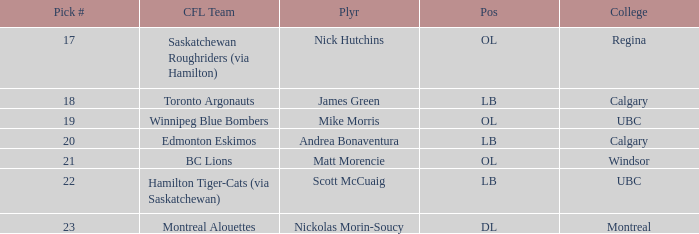Would you mind parsing the complete table? {'header': ['Pick #', 'CFL Team', 'Plyr', 'Pos', 'College'], 'rows': [['17', 'Saskatchewan Roughriders (via Hamilton)', 'Nick Hutchins', 'OL', 'Regina'], ['18', 'Toronto Argonauts', 'James Green', 'LB', 'Calgary'], ['19', 'Winnipeg Blue Bombers', 'Mike Morris', 'OL', 'UBC'], ['20', 'Edmonton Eskimos', 'Andrea Bonaventura', 'LB', 'Calgary'], ['21', 'BC Lions', 'Matt Morencie', 'OL', 'Windsor'], ['22', 'Hamilton Tiger-Cats (via Saskatchewan)', 'Scott McCuaig', 'LB', 'UBC'], ['23', 'Montreal Alouettes', 'Nickolas Morin-Soucy', 'DL', 'Montreal']]} Which player is on the BC Lions?  Matt Morencie. 